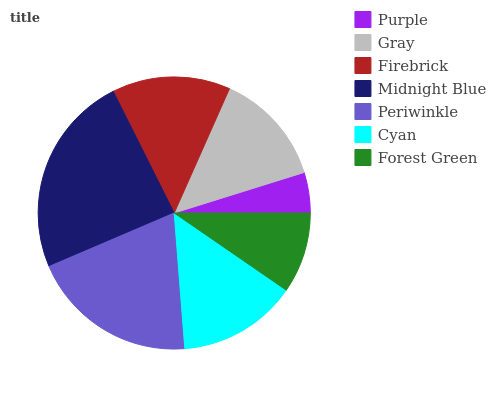Is Purple the minimum?
Answer yes or no. Yes. Is Midnight Blue the maximum?
Answer yes or no. Yes. Is Gray the minimum?
Answer yes or no. No. Is Gray the maximum?
Answer yes or no. No. Is Gray greater than Purple?
Answer yes or no. Yes. Is Purple less than Gray?
Answer yes or no. Yes. Is Purple greater than Gray?
Answer yes or no. No. Is Gray less than Purple?
Answer yes or no. No. Is Firebrick the high median?
Answer yes or no. Yes. Is Firebrick the low median?
Answer yes or no. Yes. Is Cyan the high median?
Answer yes or no. No. Is Periwinkle the low median?
Answer yes or no. No. 